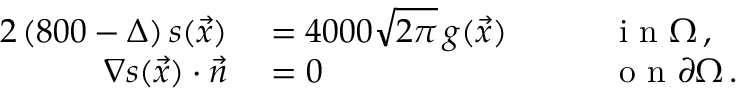<formula> <loc_0><loc_0><loc_500><loc_500>\begin{array} { r l r l } { { 2 } \left ( 8 0 0 - \Delta \right ) s ( \vec { x } ) } & = 4 0 0 0 \sqrt { 2 \pi } \, g ( \vec { x } ) \quad } & i n \Omega \, , } \\ { \nabla s ( \vec { x } ) \cdot \vec { n } } & = 0 \quad } & o n \partial \Omega \, . } \end{array}</formula> 